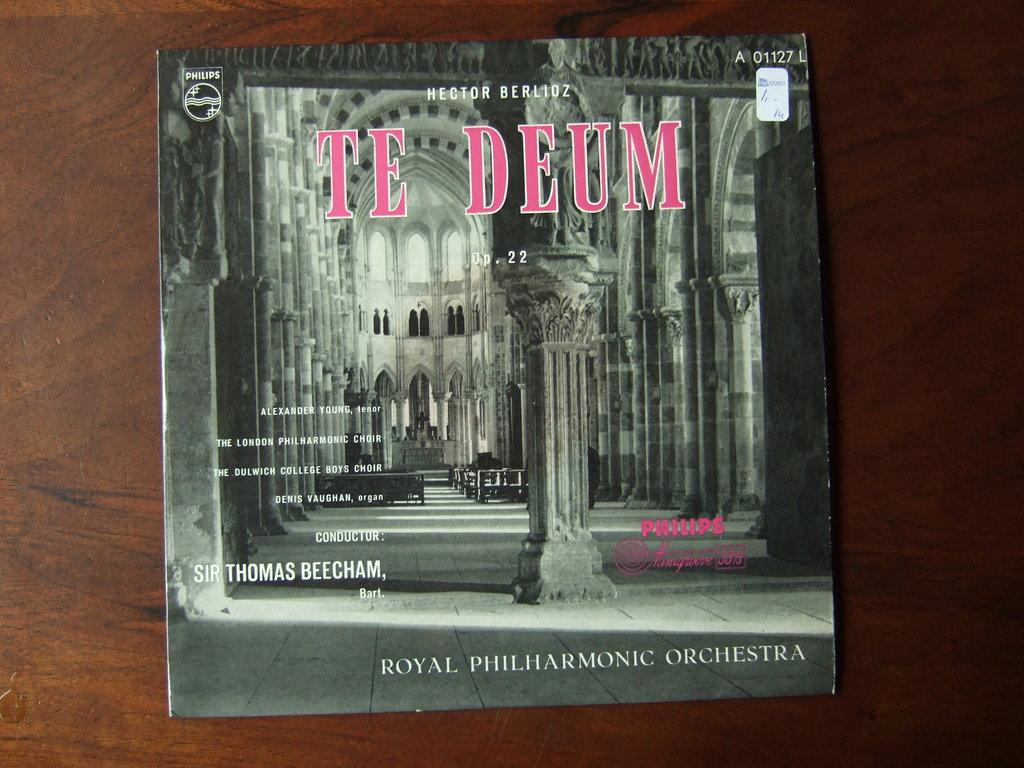Provide a one-sentence caption for the provided image. A vinyl record of the Royal Philharmonic Orchestra performing Te Deum. 